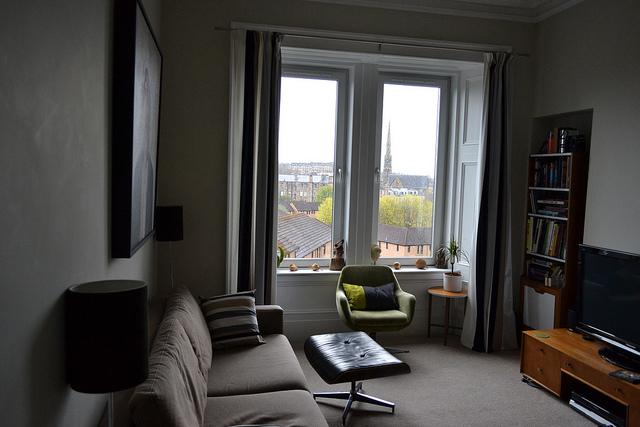What color is the left side of the pillow sitting on the single seat?

Choices:
A) black
B) yellow
C) white
D) orange yellow 